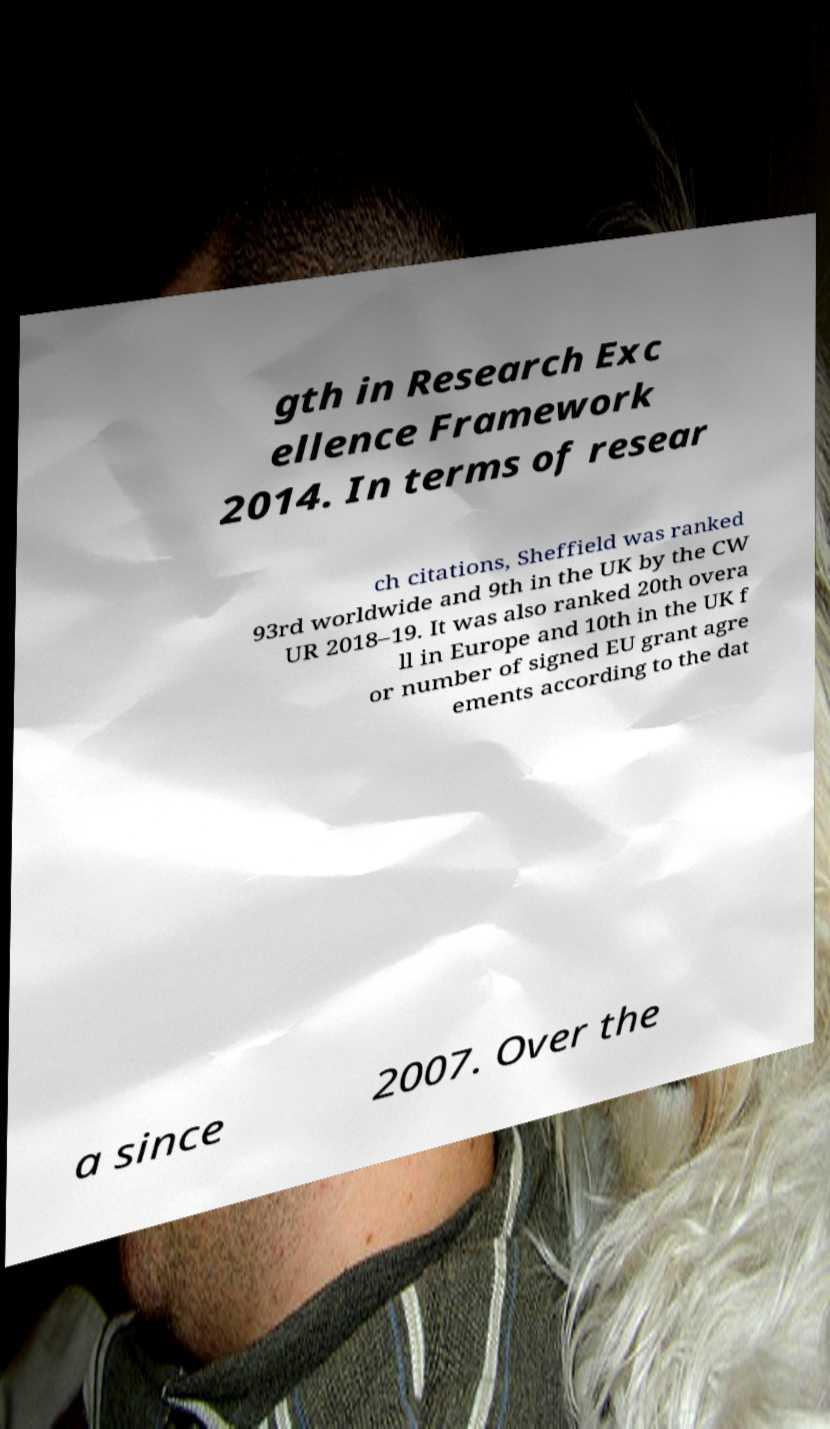Please read and relay the text visible in this image. What does it say? gth in Research Exc ellence Framework 2014. In terms of resear ch citations, Sheffield was ranked 93rd worldwide and 9th in the UK by the CW UR 2018–19. It was also ranked 20th overa ll in Europe and 10th in the UK f or number of signed EU grant agre ements according to the dat a since 2007. Over the 